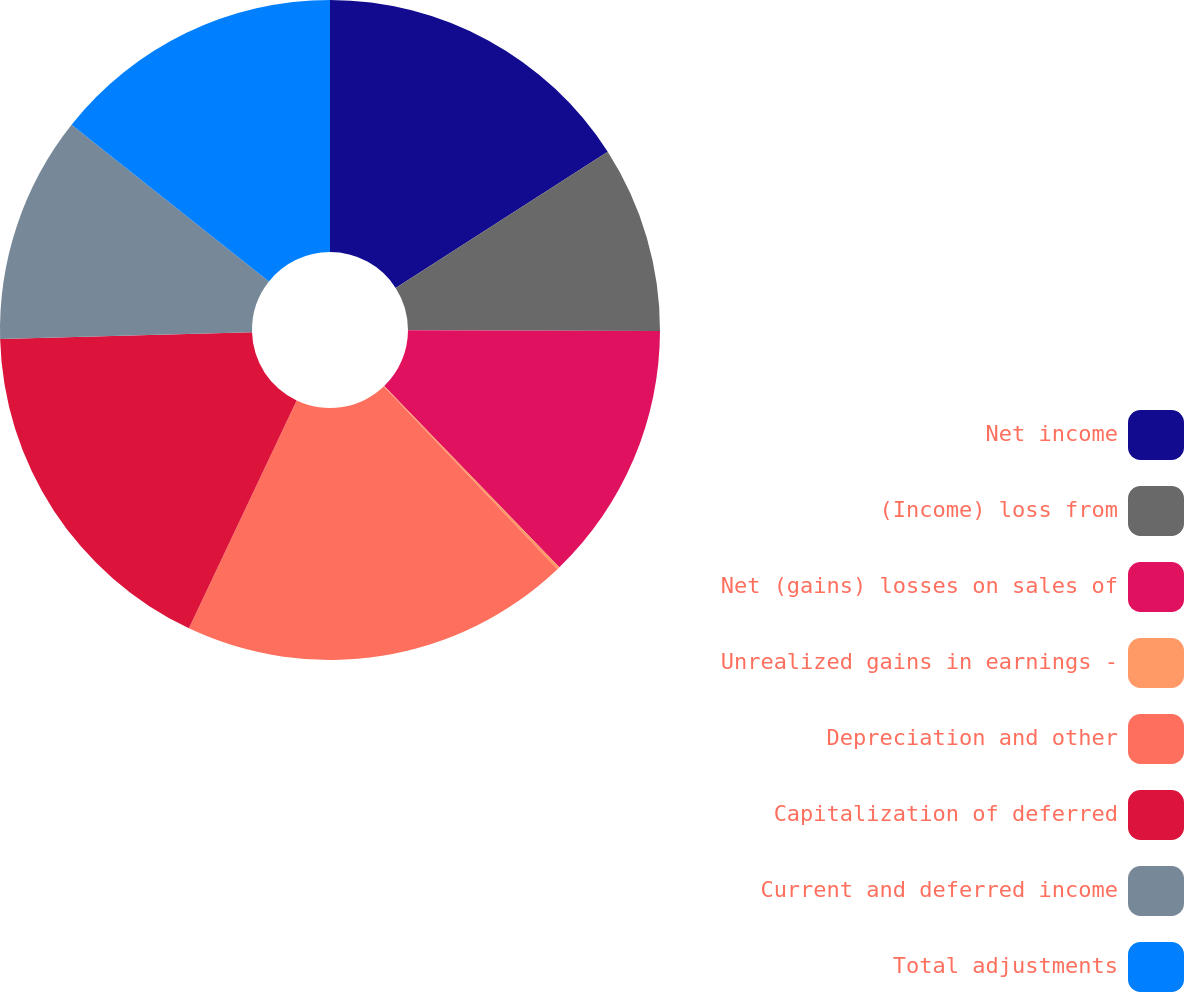<chart> <loc_0><loc_0><loc_500><loc_500><pie_chart><fcel>Net income<fcel>(Income) loss from<fcel>Net (gains) losses on sales of<fcel>Unrealized gains in earnings -<fcel>Depreciation and other<fcel>Capitalization of deferred<fcel>Current and deferred income<fcel>Total adjustments<nl><fcel>15.92%<fcel>9.13%<fcel>12.72%<fcel>0.13%<fcel>19.13%<fcel>17.53%<fcel>11.12%<fcel>14.32%<nl></chart> 